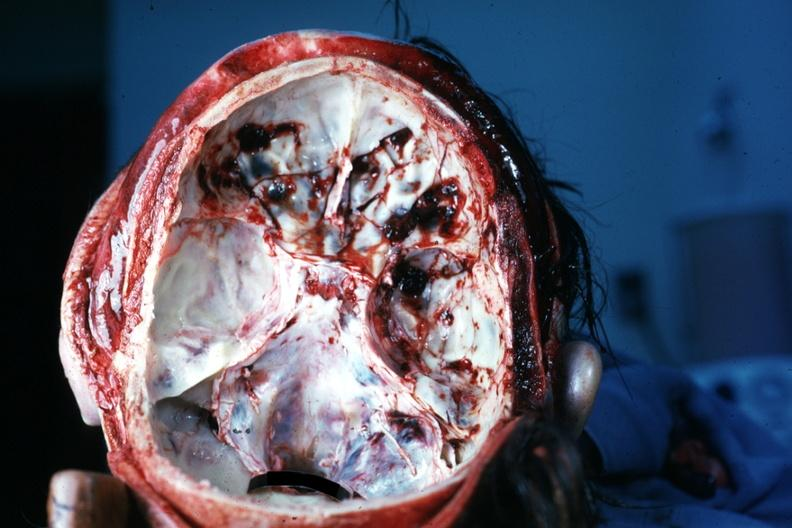what is present?
Answer the question using a single word or phrase. Bone, calvarium 